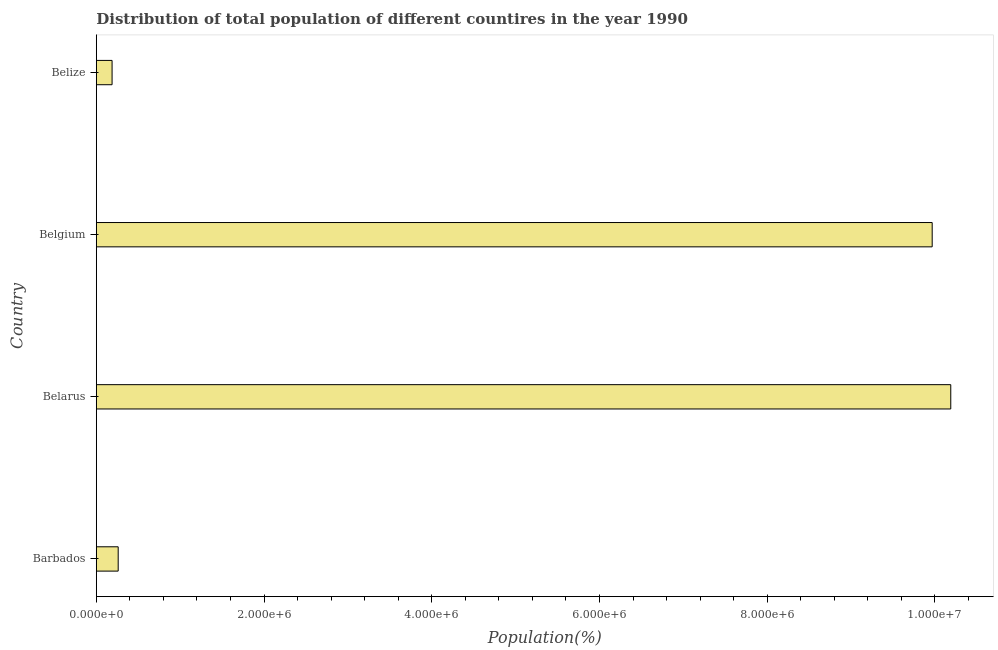Does the graph contain grids?
Offer a very short reply. No. What is the title of the graph?
Offer a very short reply. Distribution of total population of different countires in the year 1990. What is the label or title of the X-axis?
Make the answer very short. Population(%). What is the label or title of the Y-axis?
Your response must be concise. Country. What is the population in Belize?
Offer a very short reply. 1.88e+05. Across all countries, what is the maximum population?
Your answer should be very brief. 1.02e+07. Across all countries, what is the minimum population?
Make the answer very short. 1.88e+05. In which country was the population maximum?
Your answer should be very brief. Belarus. In which country was the population minimum?
Your answer should be compact. Belize. What is the sum of the population?
Offer a very short reply. 2.06e+07. What is the difference between the population in Belarus and Belgium?
Make the answer very short. 2.22e+05. What is the average population per country?
Ensure brevity in your answer.  5.15e+06. What is the median population?
Offer a very short reply. 5.11e+06. In how many countries, is the population greater than 8800000 %?
Make the answer very short. 2. What is the ratio of the population in Belgium to that in Belize?
Give a very brief answer. 53.15. Is the difference between the population in Barbados and Belgium greater than the difference between any two countries?
Ensure brevity in your answer.  No. What is the difference between the highest and the second highest population?
Your answer should be compact. 2.22e+05. What is the difference between the highest and the lowest population?
Keep it short and to the point. 1.00e+07. Are all the bars in the graph horizontal?
Provide a short and direct response. Yes. What is the Population(%) of Barbados?
Your answer should be compact. 2.60e+05. What is the Population(%) in Belarus?
Provide a short and direct response. 1.02e+07. What is the Population(%) of Belgium?
Offer a terse response. 9.97e+06. What is the Population(%) in Belize?
Provide a short and direct response. 1.88e+05. What is the difference between the Population(%) in Barbados and Belarus?
Ensure brevity in your answer.  -9.93e+06. What is the difference between the Population(%) in Barbados and Belgium?
Offer a terse response. -9.71e+06. What is the difference between the Population(%) in Barbados and Belize?
Provide a short and direct response. 7.28e+04. What is the difference between the Population(%) in Belarus and Belgium?
Provide a short and direct response. 2.22e+05. What is the difference between the Population(%) in Belarus and Belize?
Provide a short and direct response. 1.00e+07. What is the difference between the Population(%) in Belgium and Belize?
Provide a succinct answer. 9.78e+06. What is the ratio of the Population(%) in Barbados to that in Belarus?
Make the answer very short. 0.03. What is the ratio of the Population(%) in Barbados to that in Belgium?
Provide a succinct answer. 0.03. What is the ratio of the Population(%) in Barbados to that in Belize?
Your answer should be compact. 1.39. What is the ratio of the Population(%) in Belarus to that in Belgium?
Make the answer very short. 1.02. What is the ratio of the Population(%) in Belarus to that in Belize?
Your answer should be compact. 54.33. What is the ratio of the Population(%) in Belgium to that in Belize?
Offer a terse response. 53.15. 